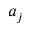Convert formula to latex. <formula><loc_0><loc_0><loc_500><loc_500>a _ { j }</formula> 